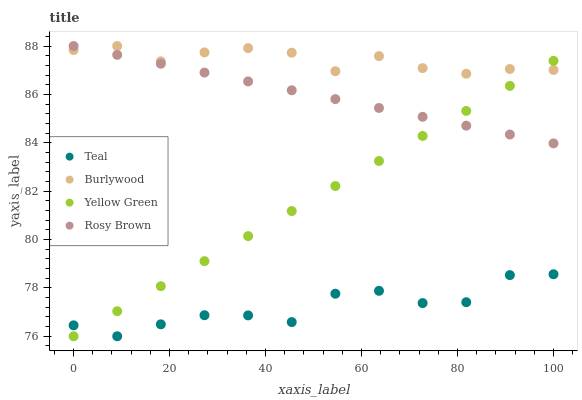Does Teal have the minimum area under the curve?
Answer yes or no. Yes. Does Burlywood have the maximum area under the curve?
Answer yes or no. Yes. Does Rosy Brown have the minimum area under the curve?
Answer yes or no. No. Does Rosy Brown have the maximum area under the curve?
Answer yes or no. No. Is Yellow Green the smoothest?
Answer yes or no. Yes. Is Teal the roughest?
Answer yes or no. Yes. Is Rosy Brown the smoothest?
Answer yes or no. No. Is Rosy Brown the roughest?
Answer yes or no. No. Does Yellow Green have the lowest value?
Answer yes or no. Yes. Does Rosy Brown have the lowest value?
Answer yes or no. No. Does Rosy Brown have the highest value?
Answer yes or no. Yes. Does Yellow Green have the highest value?
Answer yes or no. No. Is Teal less than Burlywood?
Answer yes or no. Yes. Is Rosy Brown greater than Teal?
Answer yes or no. Yes. Does Teal intersect Yellow Green?
Answer yes or no. Yes. Is Teal less than Yellow Green?
Answer yes or no. No. Is Teal greater than Yellow Green?
Answer yes or no. No. Does Teal intersect Burlywood?
Answer yes or no. No. 